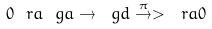Convert formula to latex. <formula><loc_0><loc_0><loc_500><loc_500>0 \ r a \ g a \rightarrow \ g d \overset { \pi } { \rightarrow } > \ r a 0</formula> 